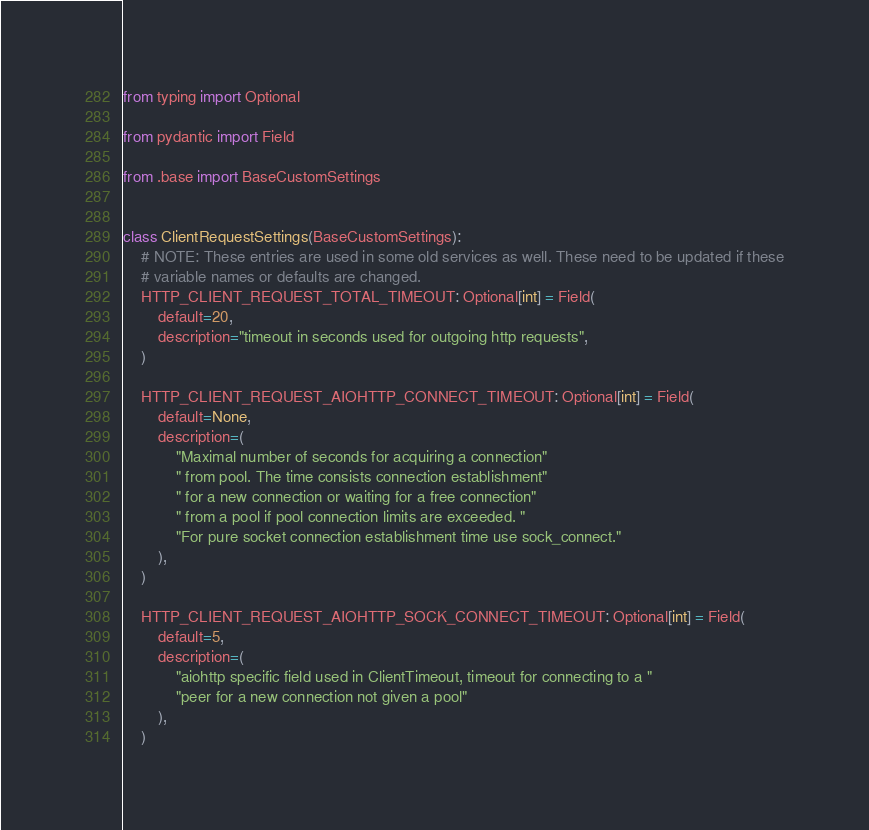<code> <loc_0><loc_0><loc_500><loc_500><_Python_>from typing import Optional

from pydantic import Field

from .base import BaseCustomSettings


class ClientRequestSettings(BaseCustomSettings):
    # NOTE: These entries are used in some old services as well. These need to be updated if these
    # variable names or defaults are changed.
    HTTP_CLIENT_REQUEST_TOTAL_TIMEOUT: Optional[int] = Field(
        default=20,
        description="timeout in seconds used for outgoing http requests",
    )

    HTTP_CLIENT_REQUEST_AIOHTTP_CONNECT_TIMEOUT: Optional[int] = Field(
        default=None,
        description=(
            "Maximal number of seconds for acquiring a connection"
            " from pool. The time consists connection establishment"
            " for a new connection or waiting for a free connection"
            " from a pool if pool connection limits are exceeded. "
            "For pure socket connection establishment time use sock_connect."
        ),
    )

    HTTP_CLIENT_REQUEST_AIOHTTP_SOCK_CONNECT_TIMEOUT: Optional[int] = Field(
        default=5,
        description=(
            "aiohttp specific field used in ClientTimeout, timeout for connecting to a "
            "peer for a new connection not given a pool"
        ),
    )
</code> 